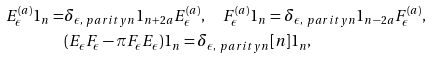Convert formula to latex. <formula><loc_0><loc_0><loc_500><loc_500>E _ { \epsilon } ^ { ( a ) } 1 _ { n } = & \delta _ { \epsilon , \ p a r i t y { n } } 1 _ { n + 2 a } E _ { \epsilon } ^ { ( a ) } , \quad F _ { \epsilon } ^ { ( a ) } 1 _ { n } = \delta _ { \epsilon , \ p a r i t y { n } } 1 _ { n - 2 a } F _ { \epsilon } ^ { ( a ) } , \\ & ( E _ { \epsilon } F _ { \epsilon } - \pi F _ { \epsilon } E _ { \epsilon } ) 1 _ { n } = \delta _ { \epsilon , \ p a r i t y n } [ n ] 1 _ { n } ,</formula> 